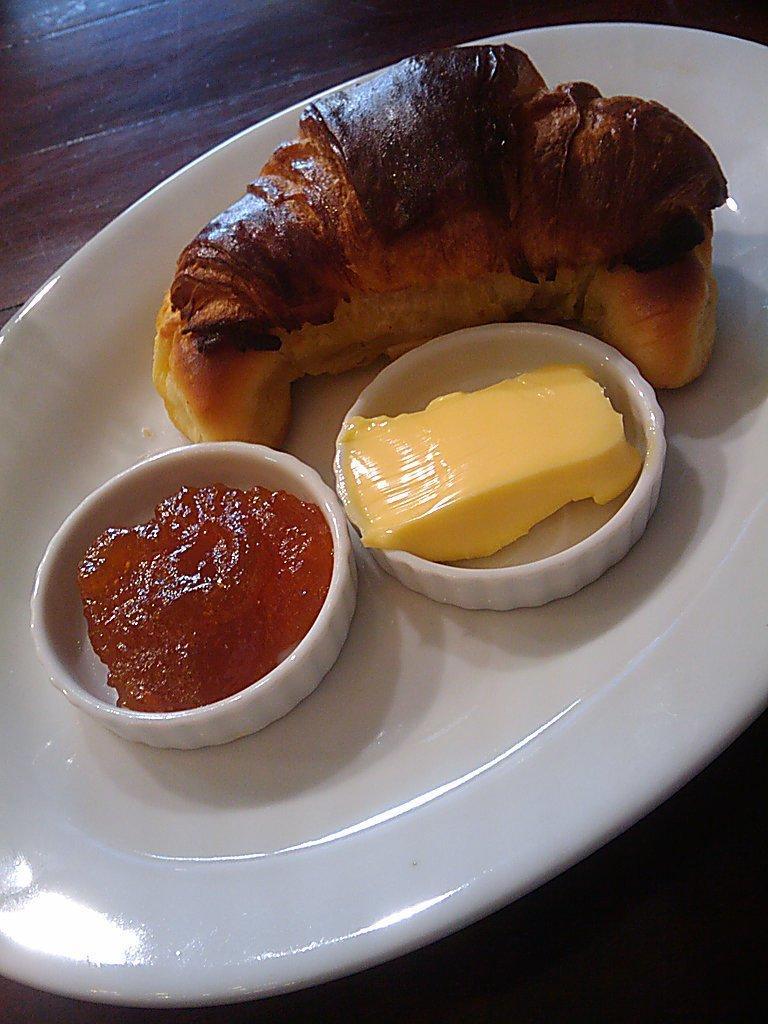Describe this image in one or two sentences. In this image we can see a plate with some food item on the table, there are two bowls on the plate with food items. 